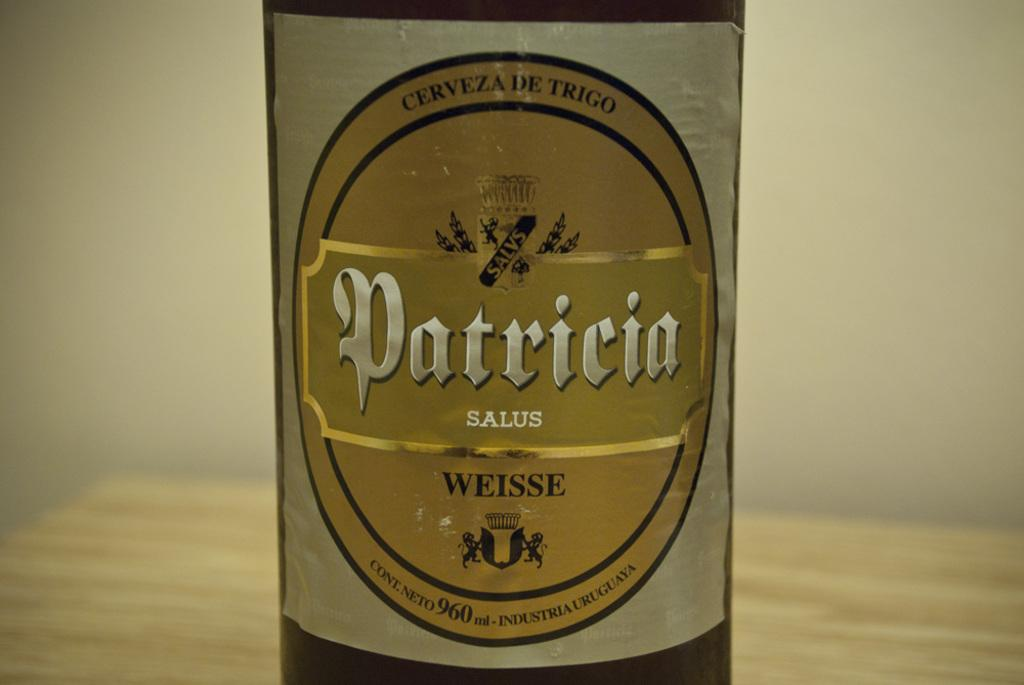What is the main object in the middle of the image? There is a bottle in the middle of the image. Are there any additional features on the bottle? Yes, the bottle has a sticker on it. What is depicted on the sticker? The sticker contains texts and animated images. How would you describe the background of the image? The background of the image is blurred. How many fans are visible in the image? There are no fans present in the image. What type of trip is being taken in the image? There is no trip depicted in the image; it features a bottle with a sticker on it. 